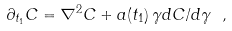Convert formula to latex. <formula><loc_0><loc_0><loc_500><loc_500>\partial _ { t _ { 1 } } C = \nabla ^ { 2 } C + a ( t _ { 1 } ) \, \gamma d C / d \gamma \ ,</formula> 